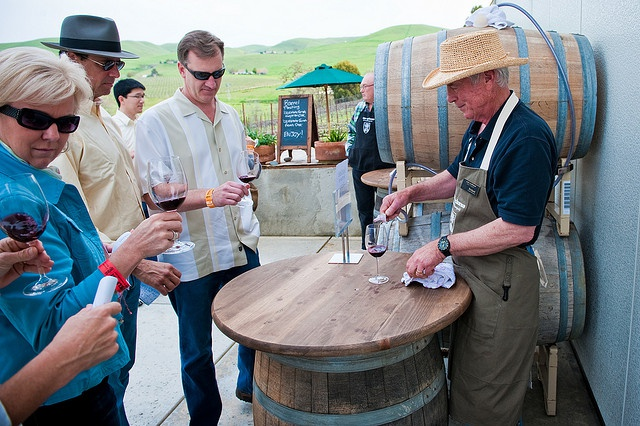Describe the objects in this image and their specific colors. I can see people in lavender, black, gray, brown, and lightpink tones, people in lavender, black, blue, teal, and brown tones, people in lavender, black, darkgray, and lightgray tones, people in lavender, darkgray, lightgray, gray, and black tones, and people in lavender, brown, maroon, and lightpink tones in this image. 